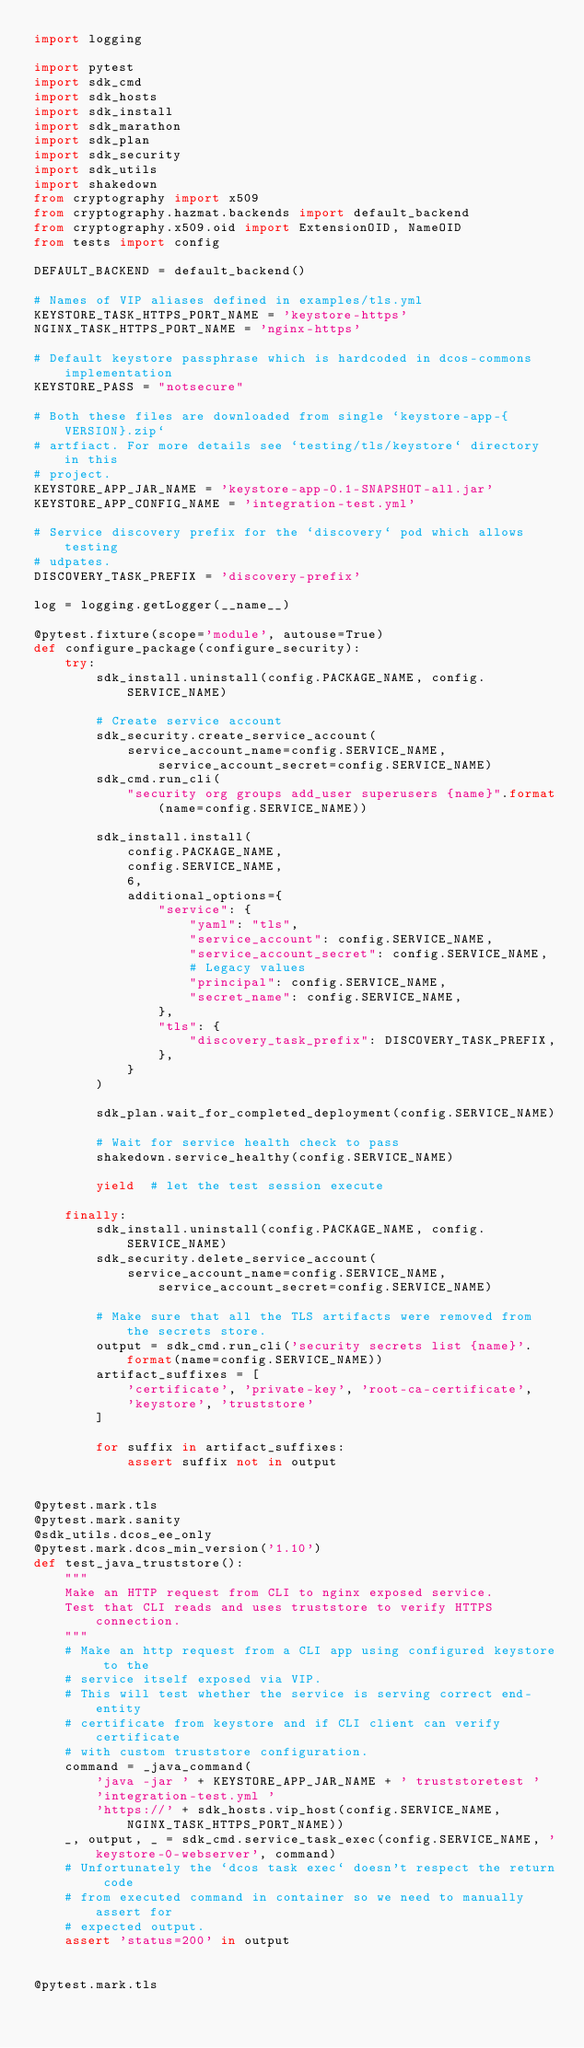<code> <loc_0><loc_0><loc_500><loc_500><_Python_>import logging

import pytest
import sdk_cmd
import sdk_hosts
import sdk_install
import sdk_marathon
import sdk_plan
import sdk_security
import sdk_utils
import shakedown
from cryptography import x509
from cryptography.hazmat.backends import default_backend
from cryptography.x509.oid import ExtensionOID, NameOID
from tests import config

DEFAULT_BACKEND = default_backend()

# Names of VIP aliases defined in examples/tls.yml
KEYSTORE_TASK_HTTPS_PORT_NAME = 'keystore-https'
NGINX_TASK_HTTPS_PORT_NAME = 'nginx-https'

# Default keystore passphrase which is hardcoded in dcos-commons implementation
KEYSTORE_PASS = "notsecure"

# Both these files are downloaded from single `keystore-app-{VERSION}.zip`
# artfiact. For more details see `testing/tls/keystore` directory in this
# project.
KEYSTORE_APP_JAR_NAME = 'keystore-app-0.1-SNAPSHOT-all.jar'
KEYSTORE_APP_CONFIG_NAME = 'integration-test.yml'

# Service discovery prefix for the `discovery` pod which allows testing
# udpates.
DISCOVERY_TASK_PREFIX = 'discovery-prefix'

log = logging.getLogger(__name__)

@pytest.fixture(scope='module', autouse=True)
def configure_package(configure_security):
    try:
        sdk_install.uninstall(config.PACKAGE_NAME, config.SERVICE_NAME)

        # Create service account
        sdk_security.create_service_account(
            service_account_name=config.SERVICE_NAME, service_account_secret=config.SERVICE_NAME)
        sdk_cmd.run_cli(
            "security org groups add_user superusers {name}".format(name=config.SERVICE_NAME))

        sdk_install.install(
            config.PACKAGE_NAME,
            config.SERVICE_NAME,
            6,
            additional_options={
                "service": {
                    "yaml": "tls",
                    "service_account": config.SERVICE_NAME,
                    "service_account_secret": config.SERVICE_NAME,
                    # Legacy values
                    "principal": config.SERVICE_NAME,
                    "secret_name": config.SERVICE_NAME,
                },
                "tls": {
                    "discovery_task_prefix": DISCOVERY_TASK_PREFIX,
                },
            }
        )

        sdk_plan.wait_for_completed_deployment(config.SERVICE_NAME)

        # Wait for service health check to pass
        shakedown.service_healthy(config.SERVICE_NAME)

        yield  # let the test session execute

    finally:
        sdk_install.uninstall(config.PACKAGE_NAME, config.SERVICE_NAME)
        sdk_security.delete_service_account(
            service_account_name=config.SERVICE_NAME, service_account_secret=config.SERVICE_NAME)

        # Make sure that all the TLS artifacts were removed from the secrets store.
        output = sdk_cmd.run_cli('security secrets list {name}'.format(name=config.SERVICE_NAME))
        artifact_suffixes = [
            'certificate', 'private-key', 'root-ca-certificate',
            'keystore', 'truststore'
        ]

        for suffix in artifact_suffixes:
            assert suffix not in output


@pytest.mark.tls
@pytest.mark.sanity
@sdk_utils.dcos_ee_only
@pytest.mark.dcos_min_version('1.10')
def test_java_truststore():
    """
    Make an HTTP request from CLI to nginx exposed service.
    Test that CLI reads and uses truststore to verify HTTPS connection.
    """
    # Make an http request from a CLI app using configured keystore to the
    # service itself exposed via VIP.
    # This will test whether the service is serving correct end-entity
    # certificate from keystore and if CLI client can verify certificate
    # with custom truststore configuration.
    command = _java_command(
        'java -jar ' + KEYSTORE_APP_JAR_NAME + ' truststoretest '
        'integration-test.yml '
        'https://' + sdk_hosts.vip_host(config.SERVICE_NAME, NGINX_TASK_HTTPS_PORT_NAME))
    _, output, _ = sdk_cmd.service_task_exec(config.SERVICE_NAME, 'keystore-0-webserver', command)
    # Unfortunately the `dcos task exec` doesn't respect the return code
    # from executed command in container so we need to manually assert for
    # expected output.
    assert 'status=200' in output


@pytest.mark.tls</code> 